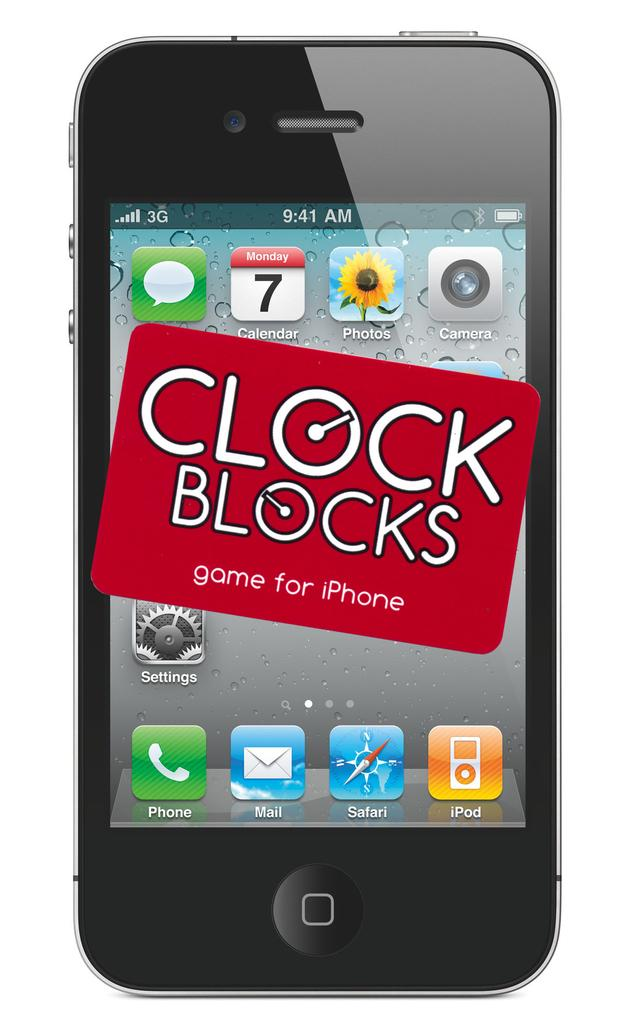<image>
Share a concise interpretation of the image provided. a phone that says clock blocks on it 